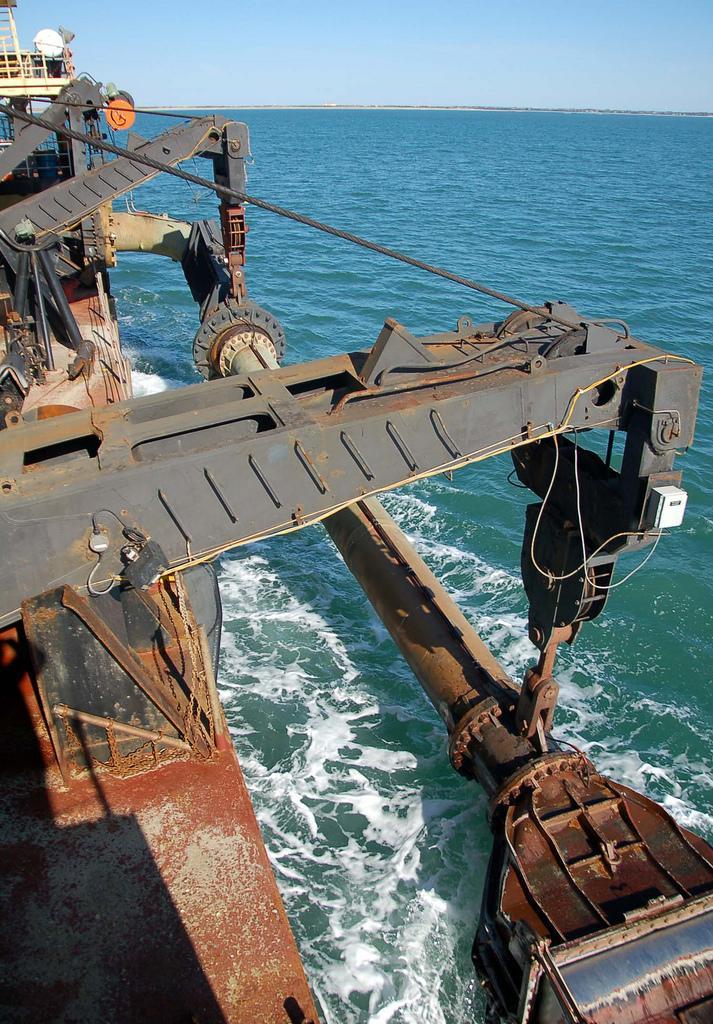Describe this image in one or two sentences. In this image I can see the sky, water and a ship over here. 